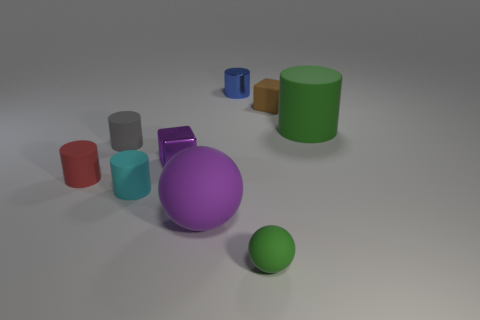Subtract all big rubber cylinders. How many cylinders are left? 4 Subtract 2 cylinders. How many cylinders are left? 3 Subtract all blue cylinders. How many cylinders are left? 4 Add 1 small purple cubes. How many objects exist? 10 Subtract all purple cylinders. Subtract all gray blocks. How many cylinders are left? 5 Subtract all blocks. How many objects are left? 7 Subtract 0 cyan blocks. How many objects are left? 9 Subtract all tiny cylinders. Subtract all small green rubber things. How many objects are left? 4 Add 6 cyan rubber cylinders. How many cyan rubber cylinders are left? 7 Add 9 metal cylinders. How many metal cylinders exist? 10 